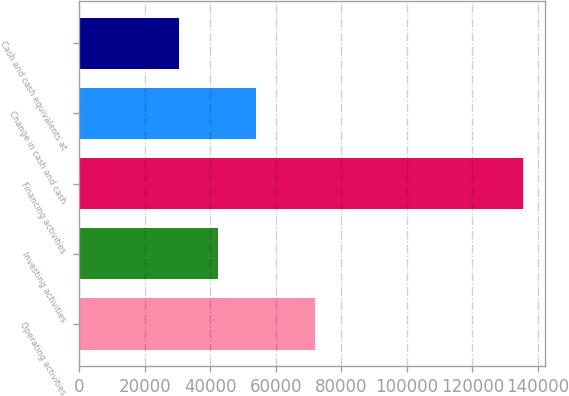Convert chart to OTSL. <chart><loc_0><loc_0><loc_500><loc_500><bar_chart><fcel>Operating activities<fcel>Investing activities<fcel>Financing activities<fcel>Change in cash and cash<fcel>Cash and cash equivalents at<nl><fcel>72100<fcel>42211.2<fcel>135532<fcel>53876.3<fcel>30546.1<nl></chart> 